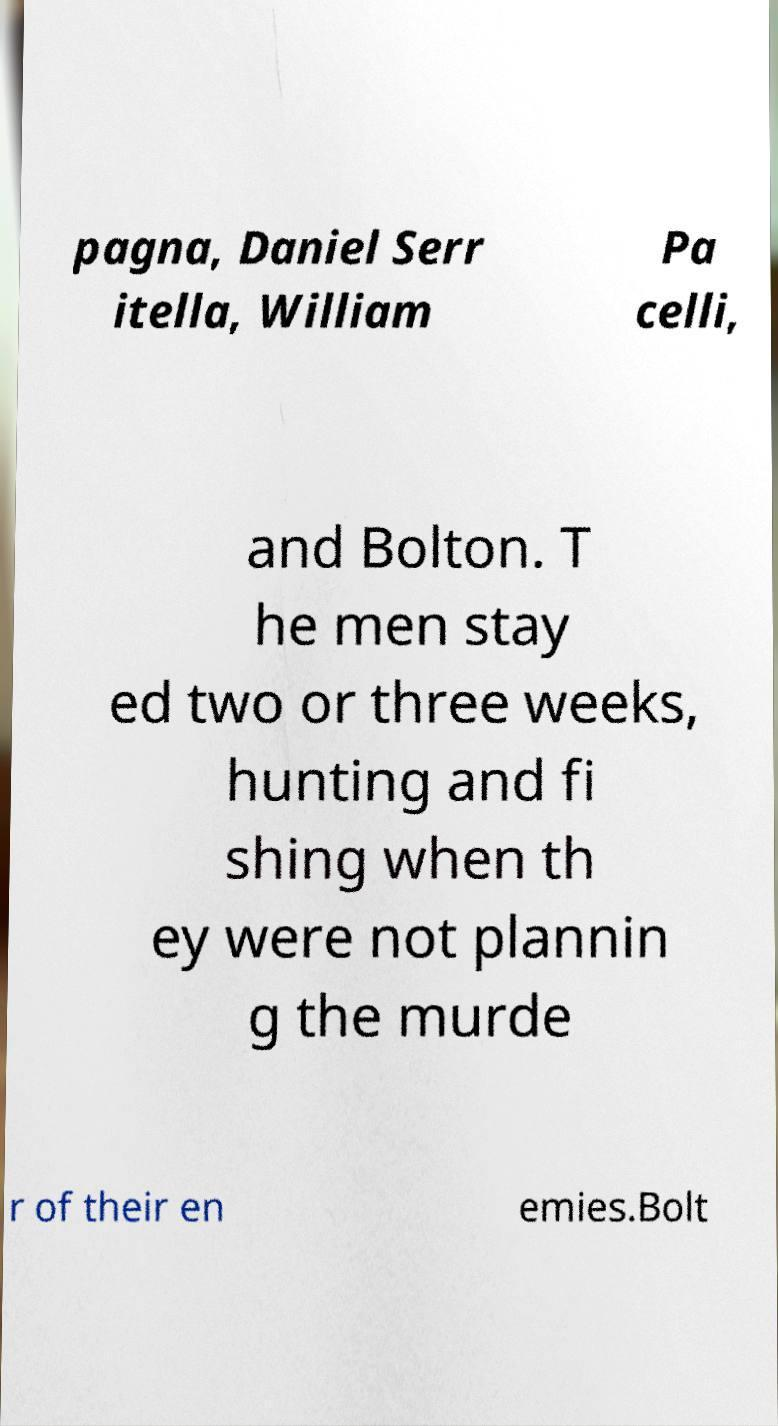Please read and relay the text visible in this image. What does it say? pagna, Daniel Serr itella, William Pa celli, and Bolton. T he men stay ed two or three weeks, hunting and fi shing when th ey were not plannin g the murde r of their en emies.Bolt 